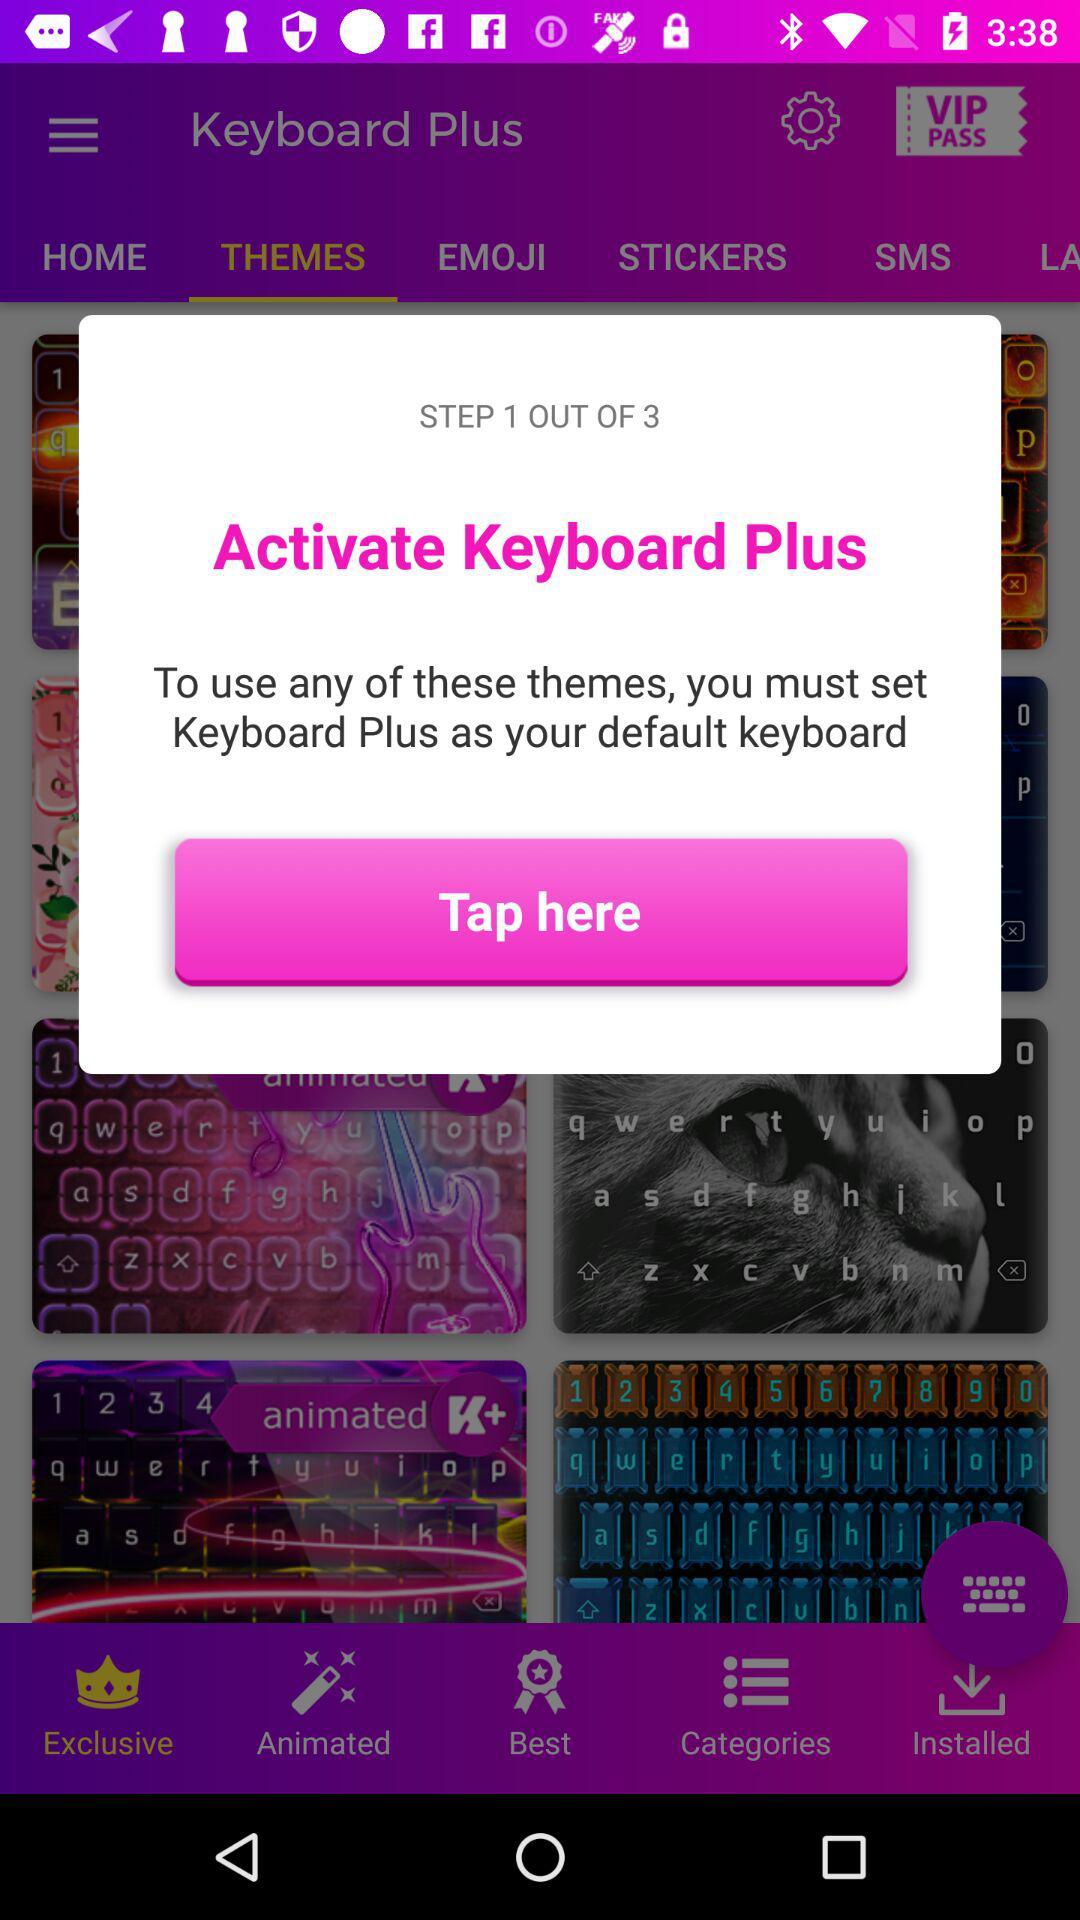How many steps are there to activate "Keyboard Plus"? There are 3 steps. 